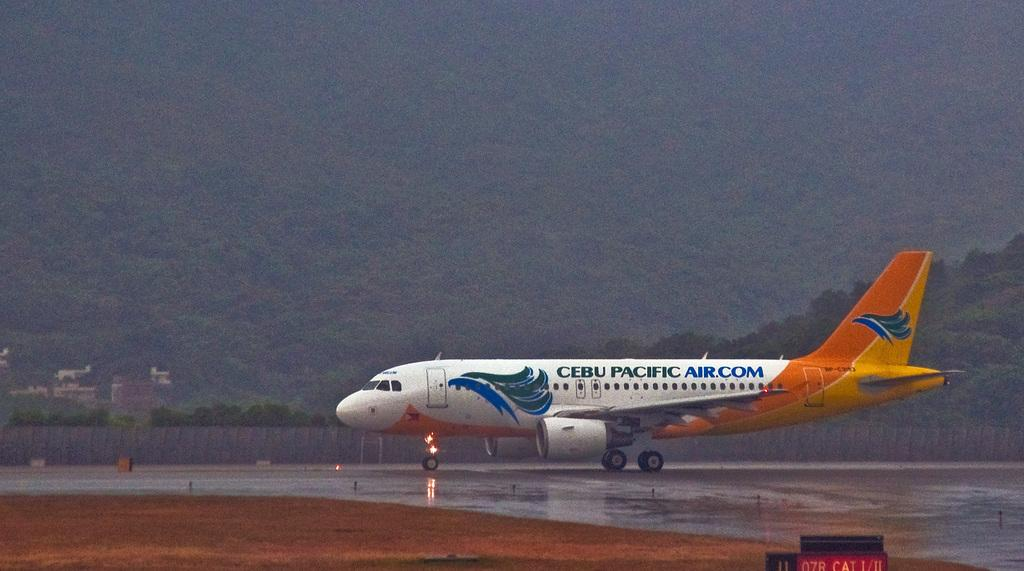What is the unusual object on the road in the image? There is an aircraft on the road in the image. What can be seen in the background of the image? There is a fence, buildings, trees, and a mountain visible in the background of the image. What type of bear can be seen walking along the fence in the image? There is no bear present in the image; it only features an aircraft on the road and various elements in the background. 